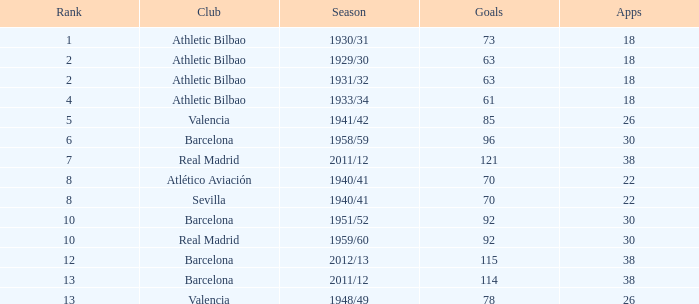Who was the club having less than 22 apps and ranked less than 2? Athletic Bilbao. 